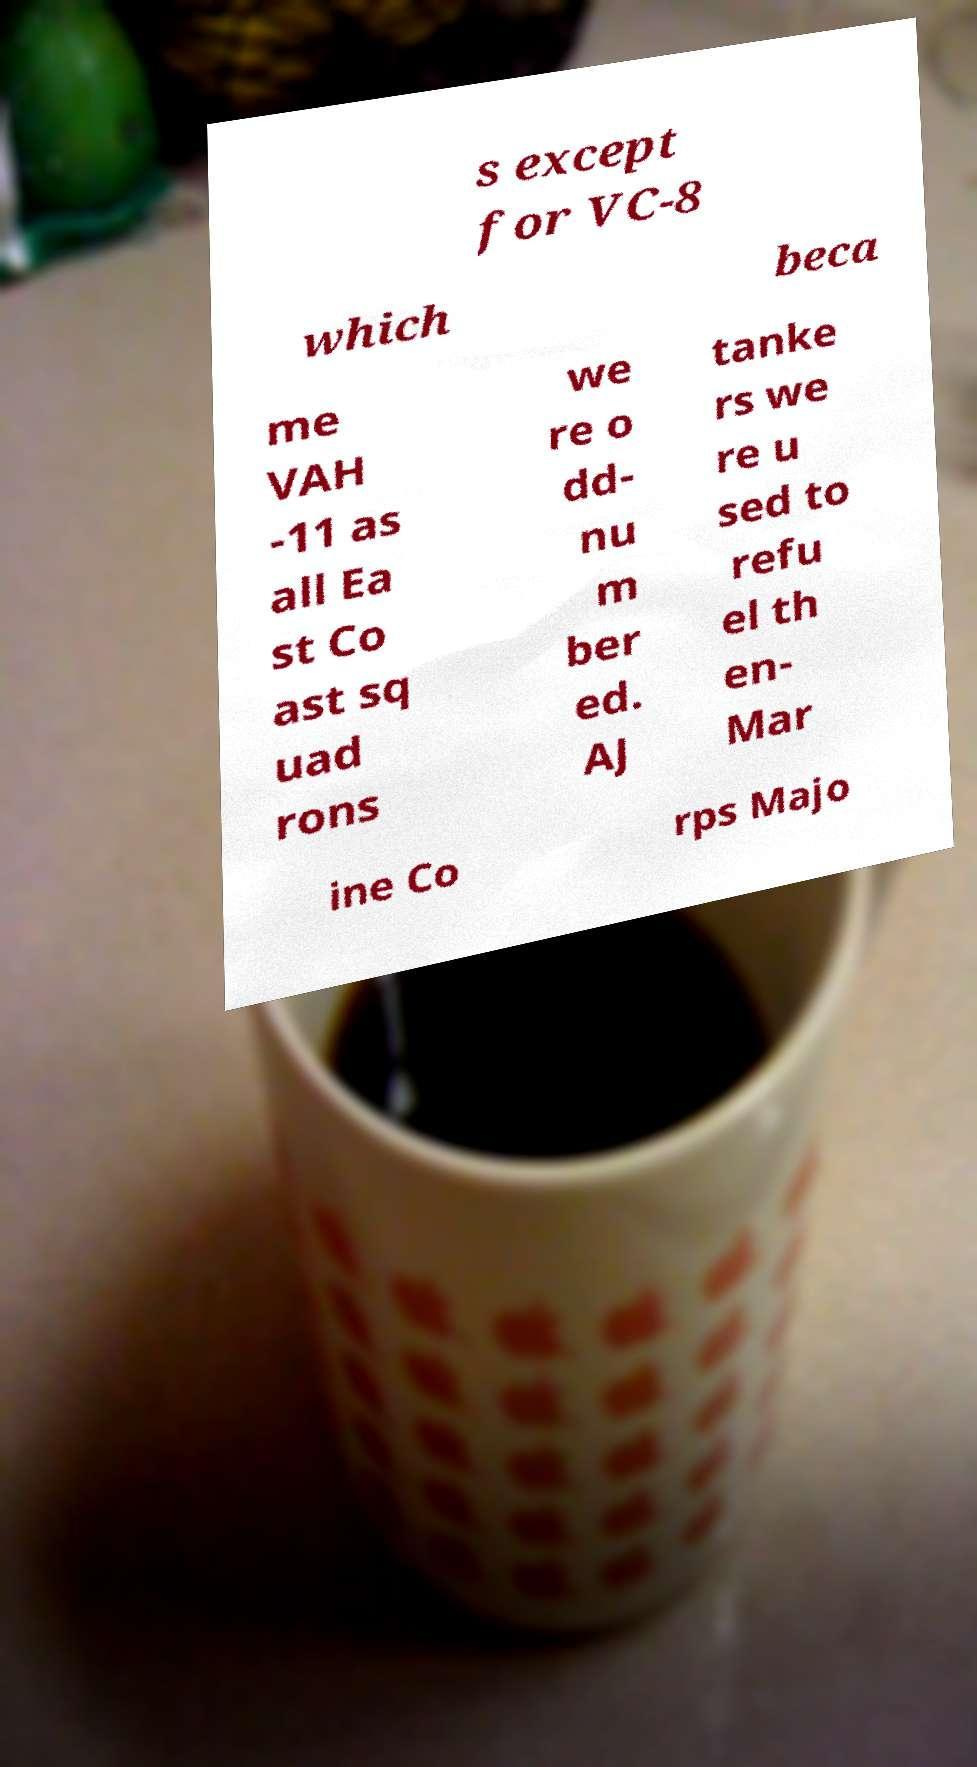Could you extract and type out the text from this image? s except for VC-8 which beca me VAH -11 as all Ea st Co ast sq uad rons we re o dd- nu m ber ed. AJ tanke rs we re u sed to refu el th en- Mar ine Co rps Majo 